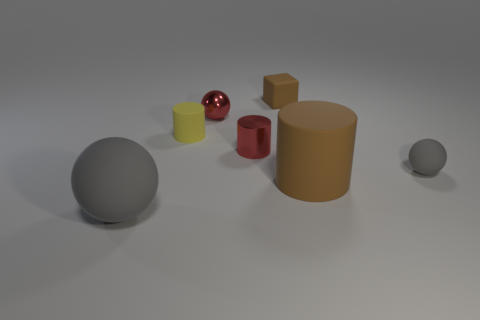What would you say is the theme or concept represented by this image? The image could be seen as an exploration of shapes and materials, expressing the contrast between geometric forms like spheres and cylinders, as well as the interplay of light and texture on different surfaces. Could there be a deeper meaning to the arrangement of these objects? One might see the arrangement as a metaphor for diversity and unity - diverse shapes, sizes, and surfaces existing harmoniously within a shared space, much like individuals in a society. 